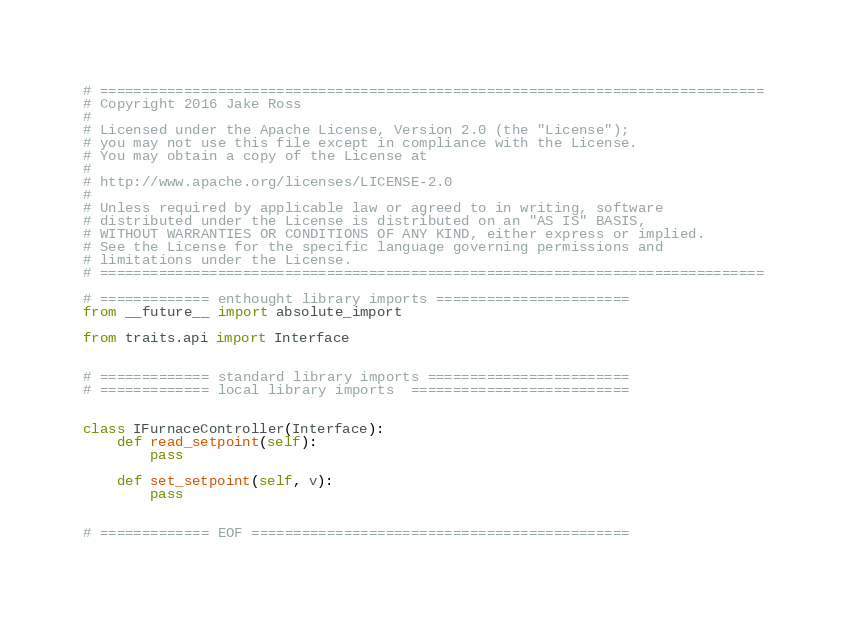Convert code to text. <code><loc_0><loc_0><loc_500><loc_500><_Python_># ===============================================================================
# Copyright 2016 Jake Ross
#
# Licensed under the Apache License, Version 2.0 (the "License");
# you may not use this file except in compliance with the License.
# You may obtain a copy of the License at
#
# http://www.apache.org/licenses/LICENSE-2.0
#
# Unless required by applicable law or agreed to in writing, software
# distributed under the License is distributed on an "AS IS" BASIS,
# WITHOUT WARRANTIES OR CONDITIONS OF ANY KIND, either express or implied.
# See the License for the specific language governing permissions and
# limitations under the License.
# ===============================================================================

# ============= enthought library imports =======================
from __future__ import absolute_import

from traits.api import Interface


# ============= standard library imports ========================
# ============= local library imports  ==========================


class IFurnaceController(Interface):
    def read_setpoint(self):
        pass

    def set_setpoint(self, v):
        pass


# ============= EOF =============================================
</code> 